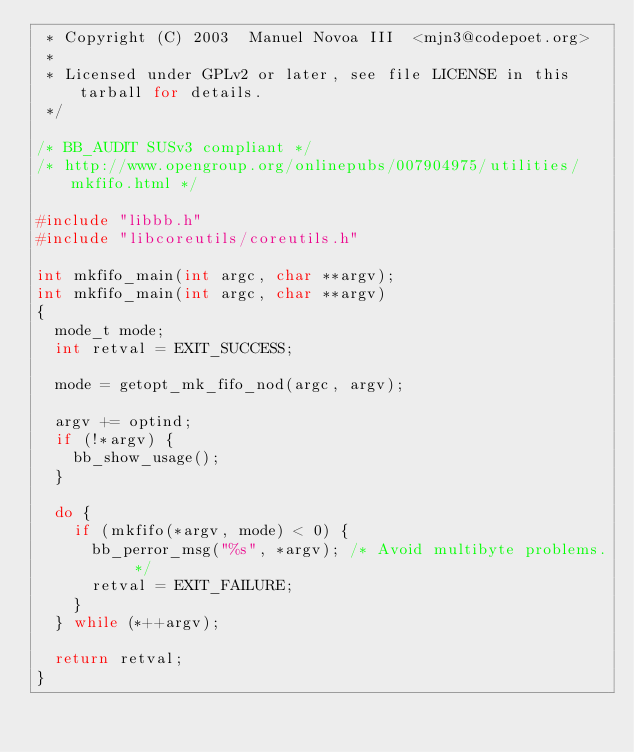<code> <loc_0><loc_0><loc_500><loc_500><_C_> * Copyright (C) 2003  Manuel Novoa III  <mjn3@codepoet.org>
 *
 * Licensed under GPLv2 or later, see file LICENSE in this tarball for details.
 */

/* BB_AUDIT SUSv3 compliant */
/* http://www.opengroup.org/onlinepubs/007904975/utilities/mkfifo.html */

#include "libbb.h"
#include "libcoreutils/coreutils.h"

int mkfifo_main(int argc, char **argv);
int mkfifo_main(int argc, char **argv)
{
	mode_t mode;
	int retval = EXIT_SUCCESS;

	mode = getopt_mk_fifo_nod(argc, argv);

	argv += optind;
	if (!*argv) {
		bb_show_usage();
	}

	do {
		if (mkfifo(*argv, mode) < 0) {
			bb_perror_msg("%s", *argv);	/* Avoid multibyte problems. */
			retval = EXIT_FAILURE;
		}
	} while (*++argv);

	return retval;
}
</code> 